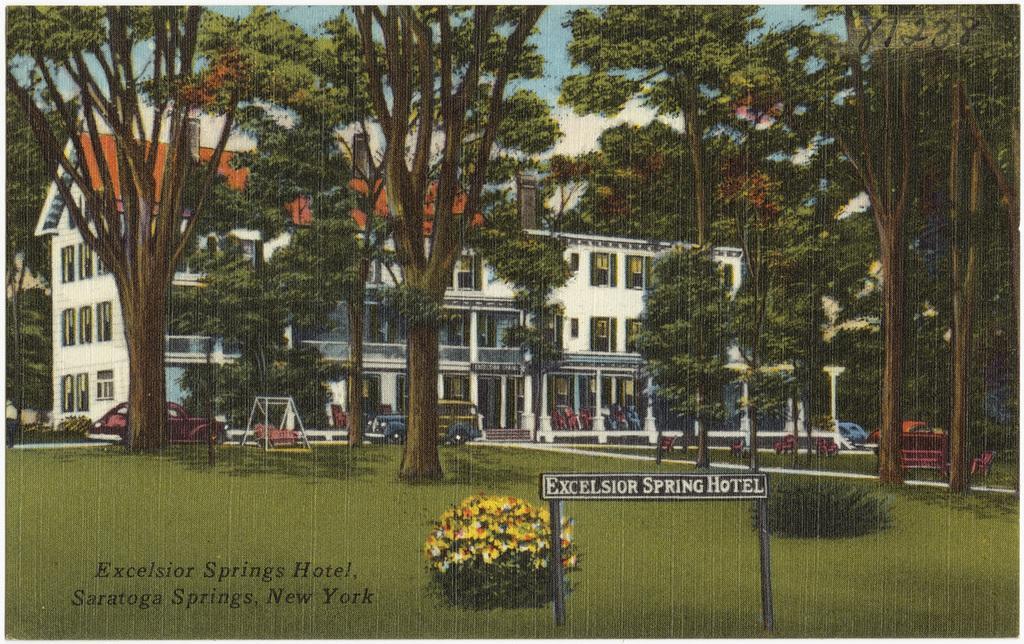Describe this image in one or two sentences. In this image we can see a building with roof, windows, stairs and pillars. We can also see some trees, bark of the trees, plants with flowers, a stand, pole and the grass. On the backside we can see the sky which looks cloudy. 